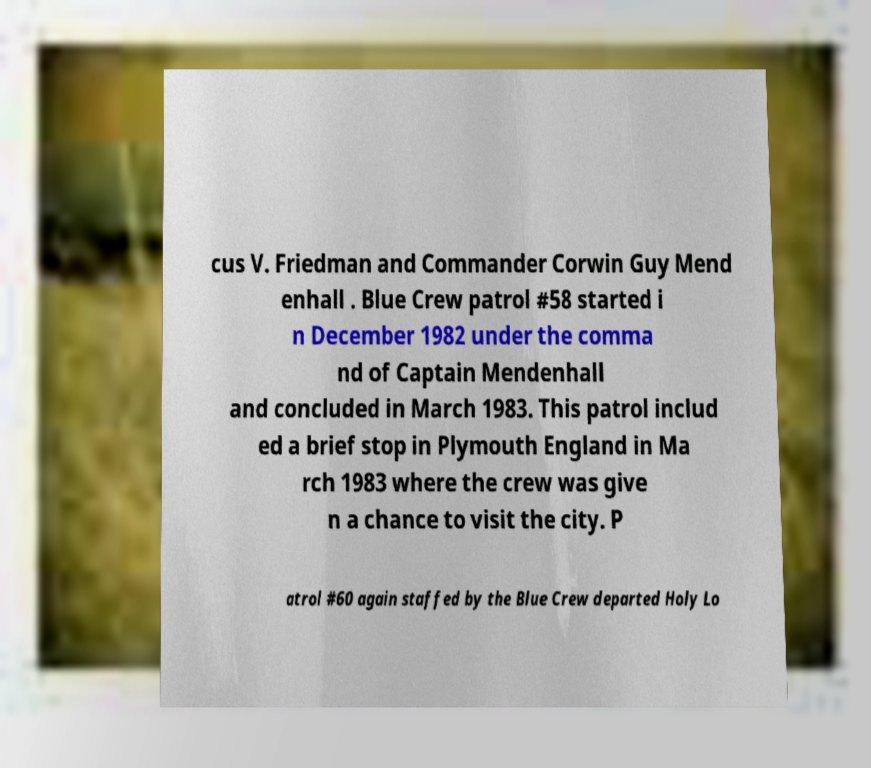Can you accurately transcribe the text from the provided image for me? cus V. Friedman and Commander Corwin Guy Mend enhall . Blue Crew patrol #58 started i n December 1982 under the comma nd of Captain Mendenhall and concluded in March 1983. This patrol includ ed a brief stop in Plymouth England in Ma rch 1983 where the crew was give n a chance to visit the city. P atrol #60 again staffed by the Blue Crew departed Holy Lo 